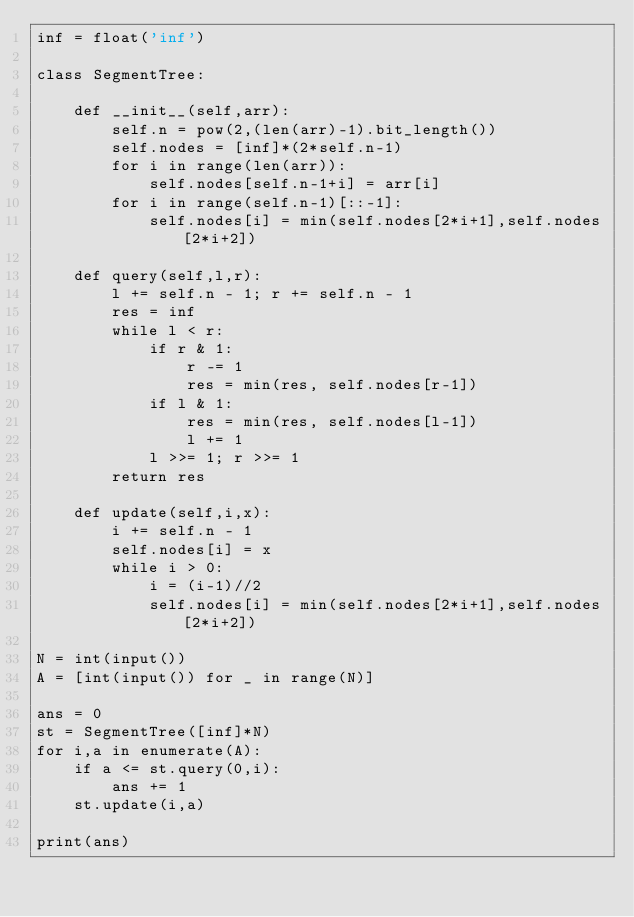Convert code to text. <code><loc_0><loc_0><loc_500><loc_500><_Python_>inf = float('inf')

class SegmentTree:

    def __init__(self,arr):
        self.n = pow(2,(len(arr)-1).bit_length())
        self.nodes = [inf]*(2*self.n-1)
        for i in range(len(arr)):
            self.nodes[self.n-1+i] = arr[i]
        for i in range(self.n-1)[::-1]:
            self.nodes[i] = min(self.nodes[2*i+1],self.nodes[2*i+2])

    def query(self,l,r):
        l += self.n - 1; r += self.n - 1
        res = inf
        while l < r:
            if r & 1:
                r -= 1
                res = min(res, self.nodes[r-1])
            if l & 1:
                res = min(res, self.nodes[l-1])
                l += 1
            l >>= 1; r >>= 1
        return res

    def update(self,i,x):
        i += self.n - 1
        self.nodes[i] = x
        while i > 0:
            i = (i-1)//2
            self.nodes[i] = min(self.nodes[2*i+1],self.nodes[2*i+2])

N = int(input())
A = [int(input()) for _ in range(N)]

ans = 0
st = SegmentTree([inf]*N)
for i,a in enumerate(A):
    if a <= st.query(0,i):
        ans += 1
    st.update(i,a)

print(ans)</code> 